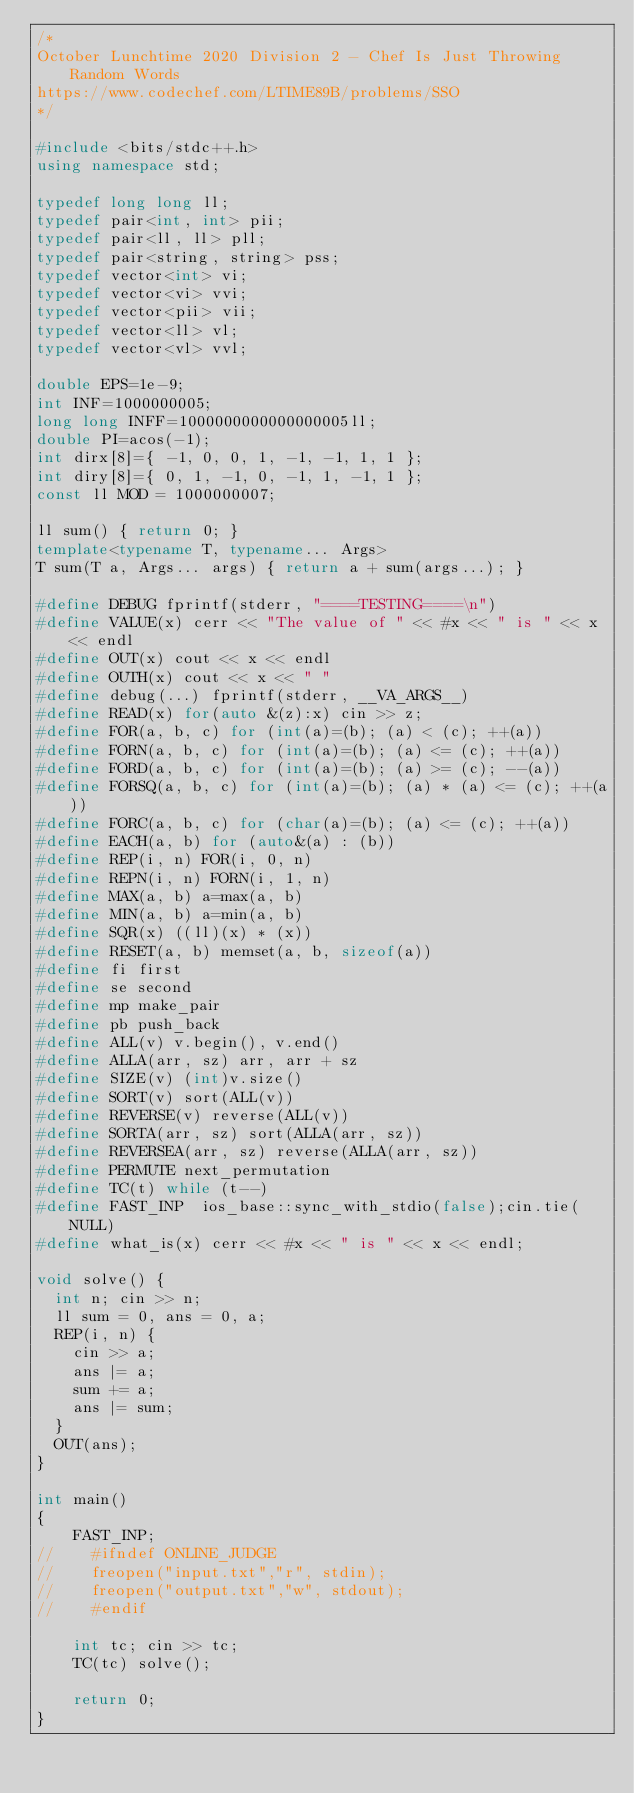<code> <loc_0><loc_0><loc_500><loc_500><_C++_>/*
October Lunchtime 2020 Division 2 - Chef Is Just Throwing Random Words
https://www.codechef.com/LTIME89B/problems/SSO
*/

#include <bits/stdc++.h>
using namespace std;

typedef long long ll;
typedef pair<int, int> pii;
typedef pair<ll, ll> pll;
typedef pair<string, string> pss;
typedef vector<int> vi;
typedef vector<vi> vvi;
typedef vector<pii> vii;
typedef vector<ll> vl;
typedef vector<vl> vvl;

double EPS=1e-9;
int INF=1000000005;
long long INFF=1000000000000000005ll;
double PI=acos(-1);
int dirx[8]={ -1, 0, 0, 1, -1, -1, 1, 1 };
int diry[8]={ 0, 1, -1, 0, -1, 1, -1, 1 };
const ll MOD = 1000000007;

ll sum() { return 0; }
template<typename T, typename... Args>
T sum(T a, Args... args) { return a + sum(args...); }

#define DEBUG fprintf(stderr, "====TESTING====\n")
#define VALUE(x) cerr << "The value of " << #x << " is " << x << endl
#define OUT(x) cout << x << endl
#define OUTH(x) cout << x << " "
#define debug(...) fprintf(stderr, __VA_ARGS__)
#define READ(x) for(auto &(z):x) cin >> z;
#define FOR(a, b, c) for (int(a)=(b); (a) < (c); ++(a))
#define FORN(a, b, c) for (int(a)=(b); (a) <= (c); ++(a))
#define FORD(a, b, c) for (int(a)=(b); (a) >= (c); --(a))
#define FORSQ(a, b, c) for (int(a)=(b); (a) * (a) <= (c); ++(a))
#define FORC(a, b, c) for (char(a)=(b); (a) <= (c); ++(a))
#define EACH(a, b) for (auto&(a) : (b))
#define REP(i, n) FOR(i, 0, n)
#define REPN(i, n) FORN(i, 1, n)
#define MAX(a, b) a=max(a, b)
#define MIN(a, b) a=min(a, b)
#define SQR(x) ((ll)(x) * (x))
#define RESET(a, b) memset(a, b, sizeof(a))
#define fi first
#define se second
#define mp make_pair
#define pb push_back
#define ALL(v) v.begin(), v.end()
#define ALLA(arr, sz) arr, arr + sz
#define SIZE(v) (int)v.size()
#define SORT(v) sort(ALL(v))
#define REVERSE(v) reverse(ALL(v))
#define SORTA(arr, sz) sort(ALLA(arr, sz))
#define REVERSEA(arr, sz) reverse(ALLA(arr, sz))
#define PERMUTE next_permutation
#define TC(t) while (t--)
#define FAST_INP  ios_base::sync_with_stdio(false);cin.tie(NULL)
#define what_is(x) cerr << #x << " is " << x << endl;

void solve() {
	int n; cin >> n;
	ll sum = 0, ans = 0, a;
	REP(i, n) {
		cin >> a;
		ans |= a;
		sum += a;
		ans |= sum;
	}
	OUT(ans);
}

int main()
{
    FAST_INP;
//    #ifndef ONLINE_JUDGE
//    freopen("input.txt","r", stdin);
//    freopen("output.txt","w", stdout);
//    #endif

    int tc; cin >> tc;
    TC(tc) solve();

    return 0;
}
</code> 